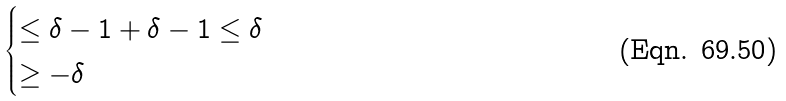Convert formula to latex. <formula><loc_0><loc_0><loc_500><loc_500>\begin{cases} \leq \delta - 1 + \delta - 1 \leq \delta \\ \geq - \delta \end{cases}</formula> 